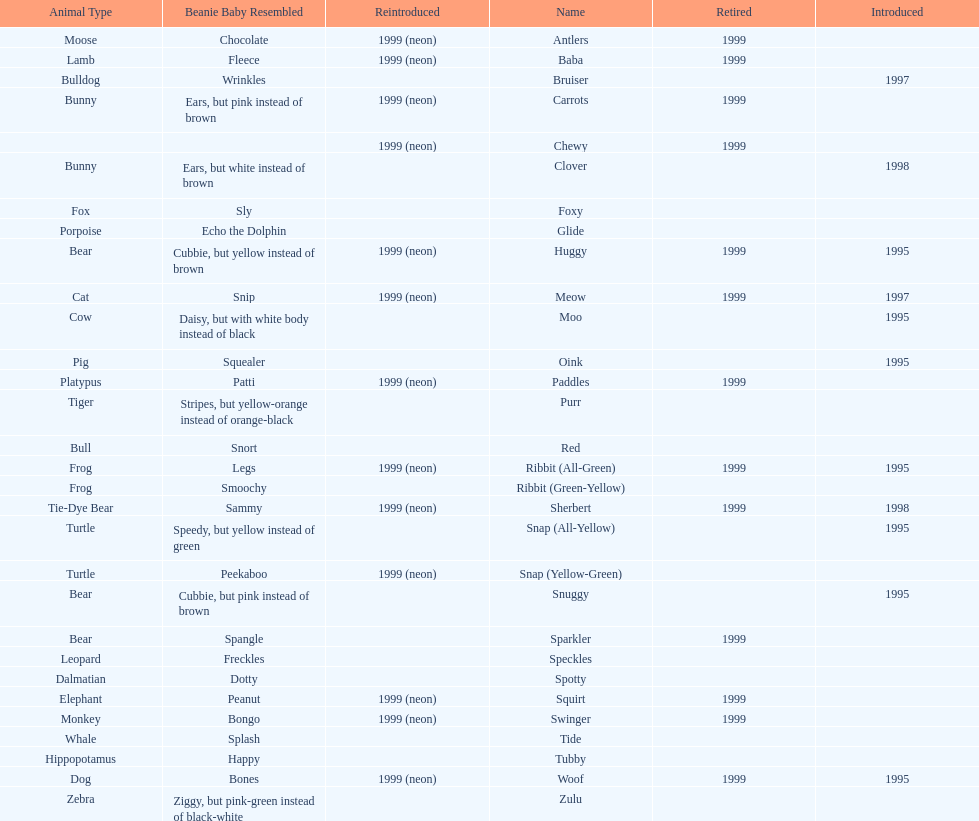What was the total number of monkey pillow pals? 1. 